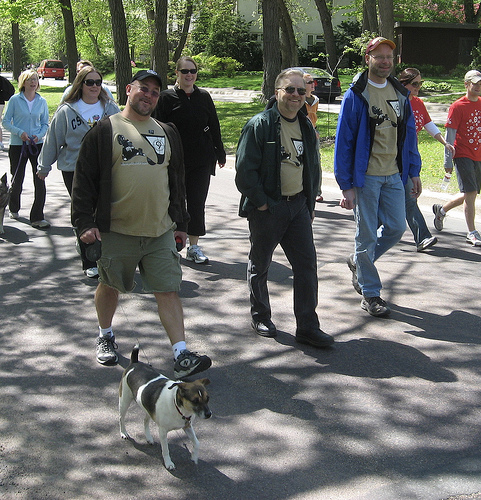<image>
Is there a dog under the man? No. The dog is not positioned under the man. The vertical relationship between these objects is different. 